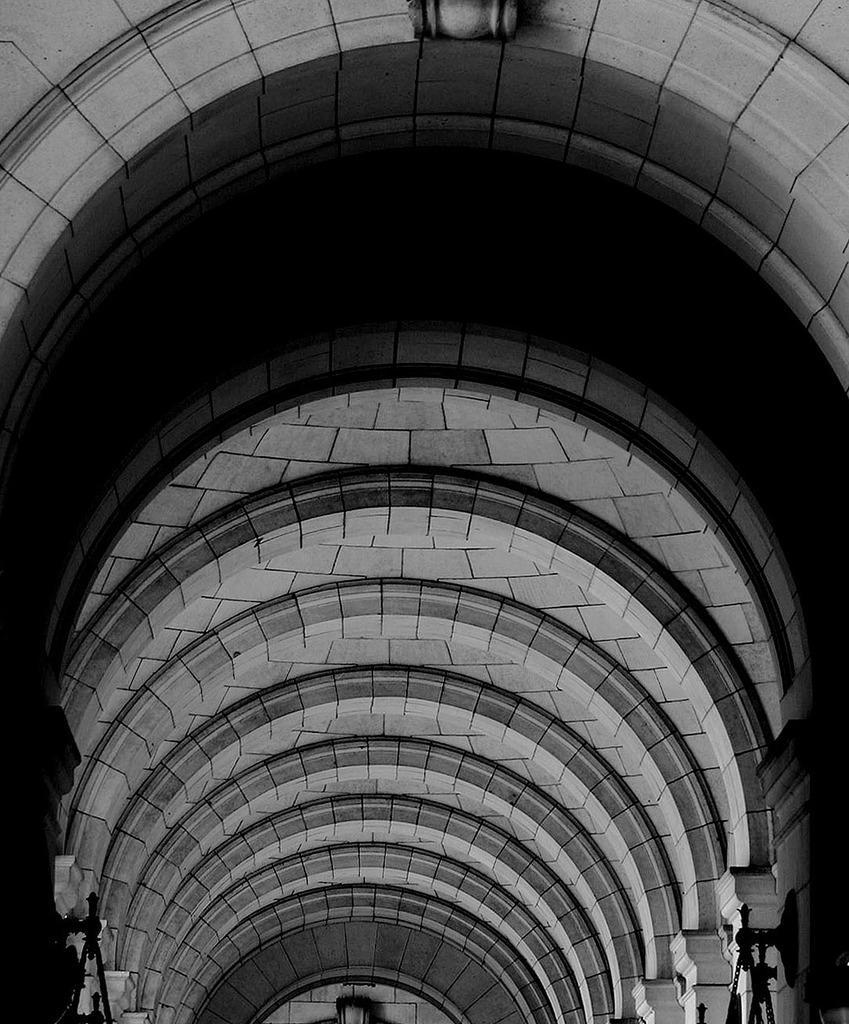Can you describe this image briefly? In this image I can see inside view of a building and on the both side of this image I can see few things. I can also see this image is black and white in colour. 